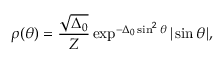<formula> <loc_0><loc_0><loc_500><loc_500>\rho ( \theta ) = \frac { \sqrt { \Delta _ { 0 } } } { Z } \exp ^ { - \Delta _ { 0 } \sin ^ { 2 } \theta } | \sin \theta | ,</formula> 